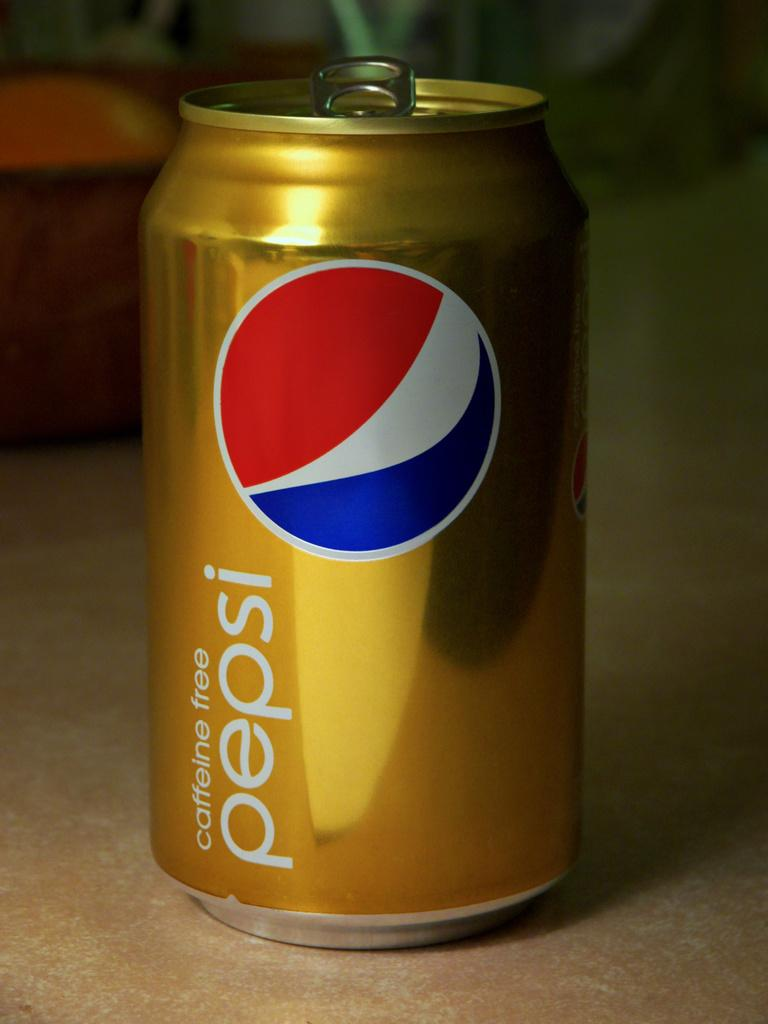<image>
Give a short and clear explanation of the subsequent image. A gold can of Pepsi is caffeine free. 